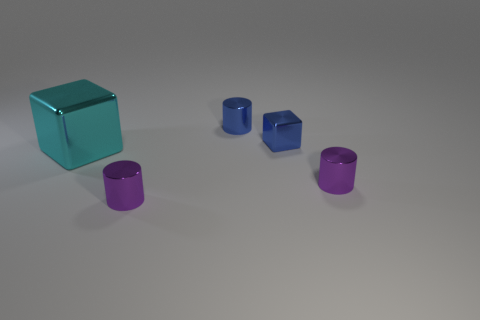Add 4 blue metallic cylinders. How many objects exist? 9 Subtract all cylinders. How many objects are left? 2 Subtract 0 green balls. How many objects are left? 5 Subtract all tiny blue metal cubes. Subtract all red matte cylinders. How many objects are left? 4 Add 3 big cyan metallic cubes. How many big cyan metallic cubes are left? 4 Add 4 green cylinders. How many green cylinders exist? 4 